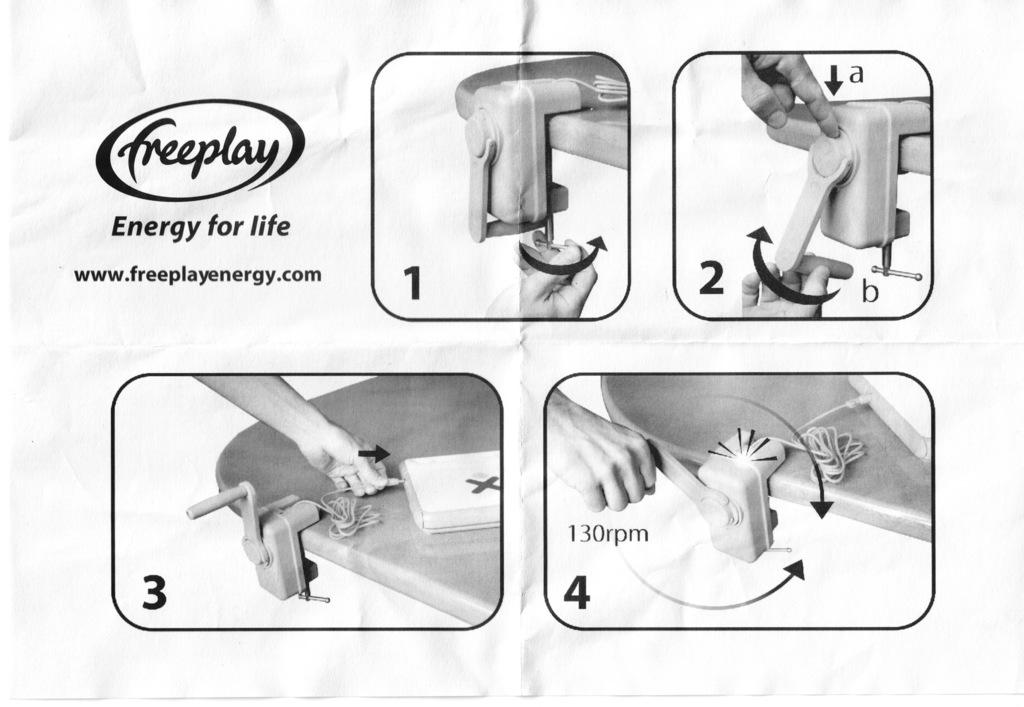What is the person in the image holding? The person is holding a device in the image. What else can be seen on the table in the image? There is a device on the table and a wire in the image. Can you describe the text at the top of the image? Unfortunately, the provided facts do not give any information about the text at the top of the image. How many devices are visible in the image? There are two devices visible in the image, one held by the person and one on the table. What type of wound can be seen on the person's hand in the image? There is no wound visible on the person's hand in the image. What kind of structure is depicted in the background of the image? The provided facts do not give any information about a structure in the background of the image. 